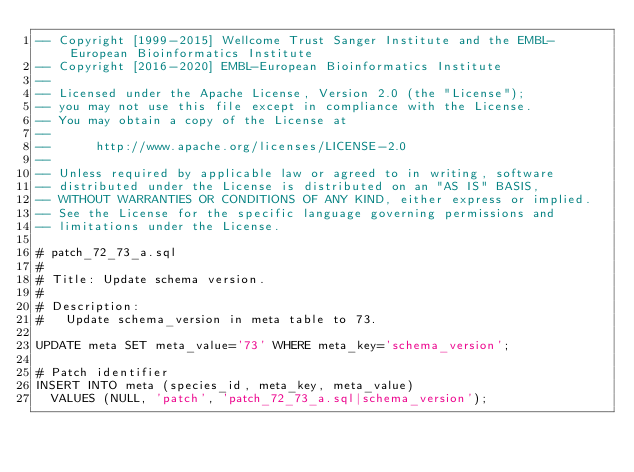Convert code to text. <code><loc_0><loc_0><loc_500><loc_500><_SQL_>-- Copyright [1999-2015] Wellcome Trust Sanger Institute and the EMBL-European Bioinformatics Institute
-- Copyright [2016-2020] EMBL-European Bioinformatics Institute
-- 
-- Licensed under the Apache License, Version 2.0 (the "License");
-- you may not use this file except in compliance with the License.
-- You may obtain a copy of the License at
-- 
--      http://www.apache.org/licenses/LICENSE-2.0
-- 
-- Unless required by applicable law or agreed to in writing, software
-- distributed under the License is distributed on an "AS IS" BASIS,
-- WITHOUT WARRANTIES OR CONDITIONS OF ANY KIND, either express or implied.
-- See the License for the specific language governing permissions and
-- limitations under the License.

# patch_72_73_a.sql
#
# Title: Update schema version.
#
# Description:
#   Update schema_version in meta table to 73.

UPDATE meta SET meta_value='73' WHERE meta_key='schema_version';

# Patch identifier
INSERT INTO meta (species_id, meta_key, meta_value)
  VALUES (NULL, 'patch', 'patch_72_73_a.sql|schema_version');
</code> 